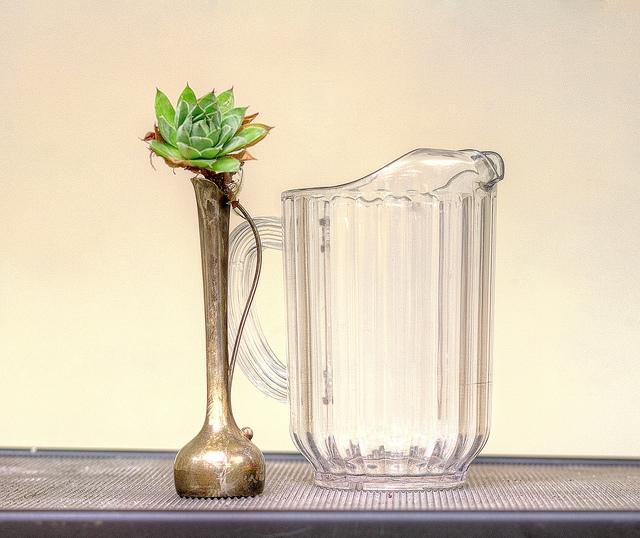What are they showing with this display?

Choices:
A) possibilities
B) randomness
C) contrast
D) colors contrast 